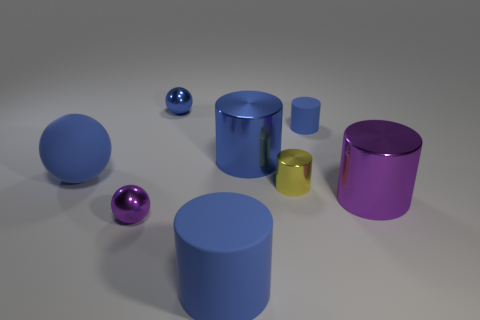Subtract all small matte cylinders. How many cylinders are left? 4 Add 1 small purple metal balls. How many objects exist? 9 Subtract all purple cylinders. How many blue spheres are left? 2 Subtract 3 spheres. How many spheres are left? 0 Subtract all purple cylinders. How many cylinders are left? 4 Subtract all cylinders. How many objects are left? 3 Add 6 large blue cylinders. How many large blue cylinders are left? 8 Add 6 large blue spheres. How many large blue spheres exist? 7 Subtract 0 yellow spheres. How many objects are left? 8 Subtract all yellow cylinders. Subtract all red blocks. How many cylinders are left? 4 